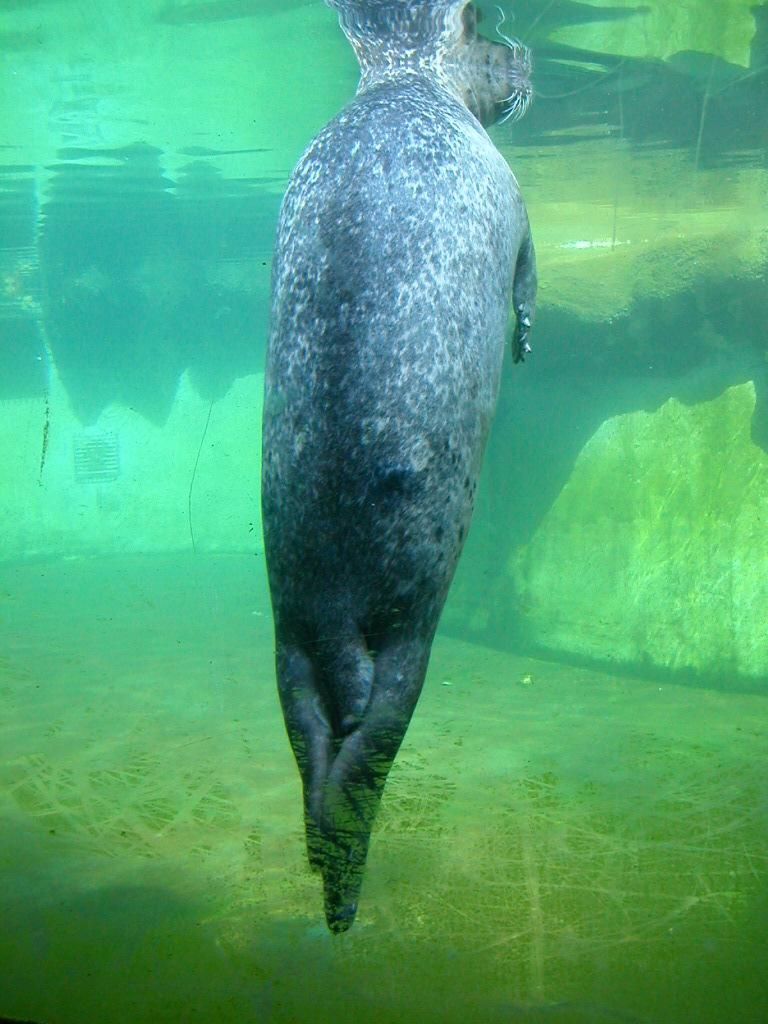What is the animal doing in the water in the image? The fact provided does not specify what the animal is doing in the water. What structure can be seen in the image? There is a wall visible in the image. What type of pencil is the animal using to swim in the image? There is no pencil present in the image, and animals do not use pencils to swim. 